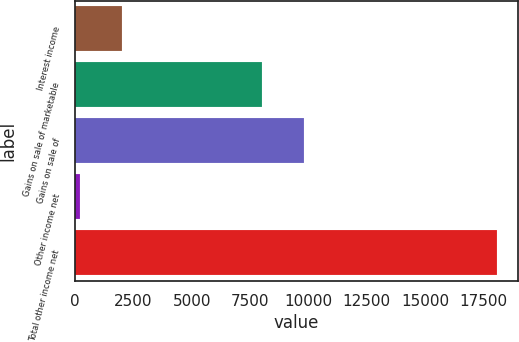Convert chart to OTSL. <chart><loc_0><loc_0><loc_500><loc_500><bar_chart><fcel>Interest income<fcel>Gains on sale of marketable<fcel>Gains on sale of<fcel>Other income net<fcel>Total other income net<nl><fcel>1999.1<fcel>8009<fcel>9795.1<fcel>213<fcel>18074<nl></chart> 